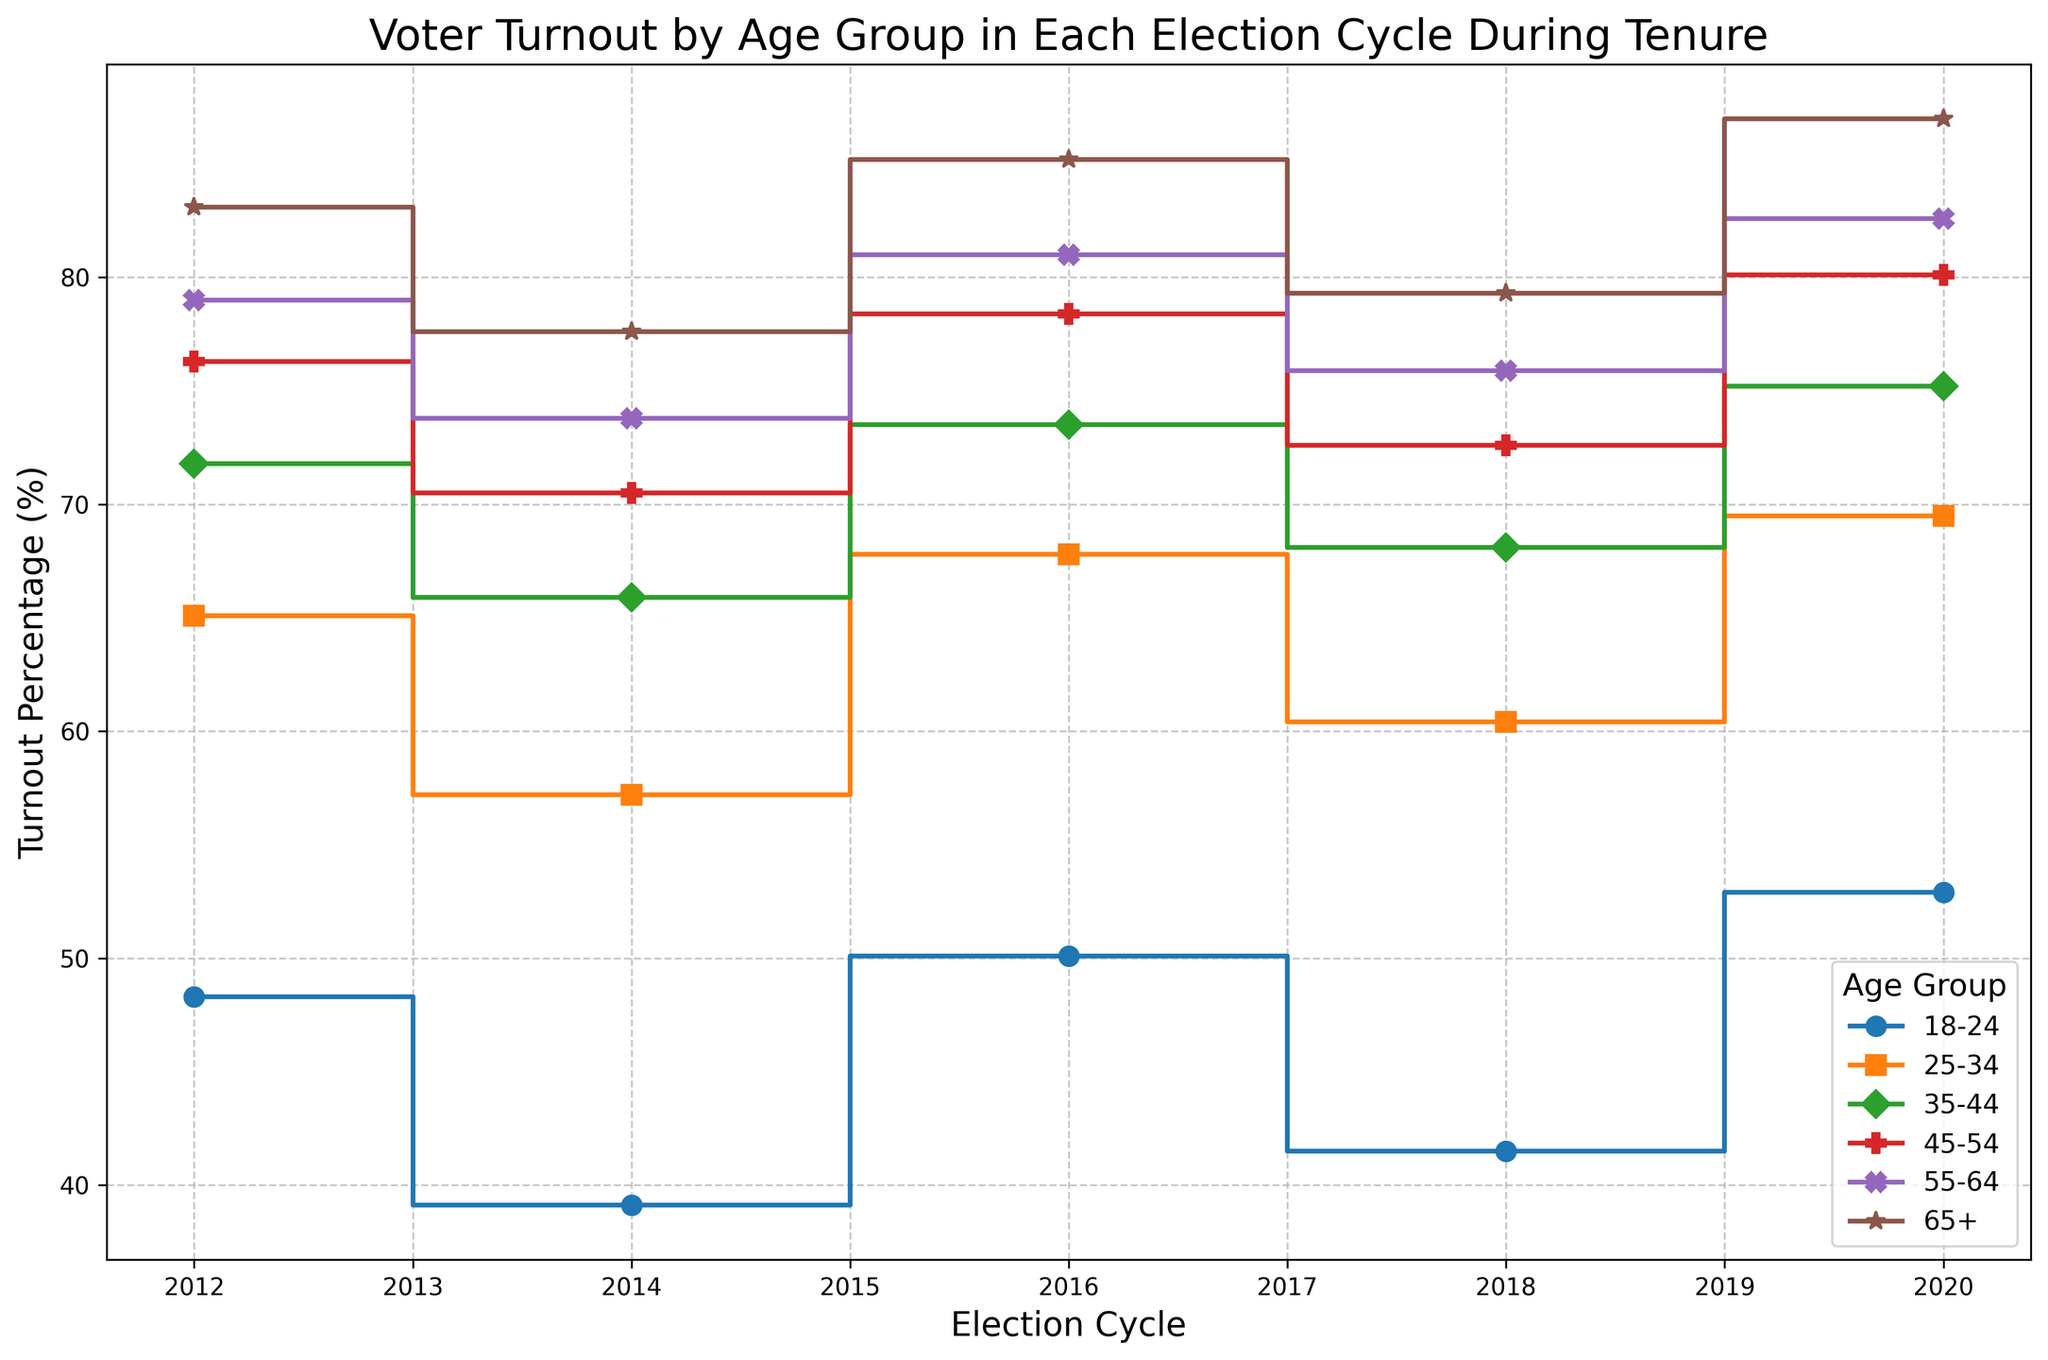Which age group had the highest voter turnout percentage in the 2020 election cycle? By looking at the figure, the group with the highest voter turnout in 2020 is indicated by the highest point on the chart at the 2020 mark. The 65+ age group has the highest turnout at 87.0%.
Answer: 65+ Which age group had the lowest voter turnout percentage in the 2014 election cycle? By examining the figure, the group with the lowest voter turnout in 2014 is indicated by the lowest point on the chart at the 2014 mark. The 18-24 age group has the lowest turnout at 39.1%.
Answer: 18-24 How did voter turnout change for the 35-44 age group from 2012 to 2016? To determine this, observe the turnout percentages for the 35-44 age group in 2012 and 2016 and find the difference. In 2012, the turnout was 71.8%, and in 2016, it was 73.5%. The increase is 73.5% - 71.8% = 1.7%.
Answer: Increased by 1.7% What is the average voter turnout percentage across all age groups in the 2018 election cycle? Calculate the average by summing the voter turnout percentages for each age group in 2018 and dividing by the number of age groups. The sum is 41.5% + 60.4% + 68.1% + 72.6% + 75.9% + 79.3% = 397.8%. Divided by 6, the average is 397.8% / 6 ≈ 66.3%.
Answer: 66.3% Which age group experienced the largest absolute increase in voter turnout percentage between 2016 and 2020? Compare the differences in turnout percentages for each age group from 2016 to 2020, finding the absolute values. The differences are as follows: 18-24: 2.8%, 25-34: 1.7%, 35-44: 1.7%, 45-54: 1.7%, 55-64: 1.6%, 65+: 1.8%. The age group 18-24 showed the largest absolute increase at 2.8%.
Answer: 18-24 What is the trend in voter turnout for the 18-24 age group over the election cycles presented? Identify the turnout percentages for the 18-24 age group across all election cycles and observe the trend: 48.3% in 2012, 39.1% in 2014, 50.1% in 2016, 41.5% in 2018, and 52.9% in 2020. The turnout fluctuates but generally increases towards 2020.
Answer: Fluctuating increase What is the difference in voter turnout between the 25-34 and 55-64 age groups in the 2014 election cycle? Find the voter turnout percentages for both groups in 2014, and then calculate the difference. For 25-34, the turnout is 57.2%, and for 55-64, it is 73.8%. The difference is 73.8% - 57.2% = 16.6%.
Answer: 16.6% Which age group showed a consistent increase in voter turnout percentage across all the election cycles? Identify any age group that consistently shows increased percentages across all given election cycles by looking at each point on the plot. The 65+ age group increases in every election cycle: 83.1% in 2012, 77.6% in 2014, 85.2% in 2016, 79.3% in 2018, and 87.0% in 2020.
Answer: 65+ In the 2016 election cycle, which age group had a turnout percentage closest to 70%? Examine the turnout percentages for all age groups in 2016 and find the one closest to 70%. The 25-34 age group had a turnout of 67.8%, which is closest to 70%.
Answer: 25-34 